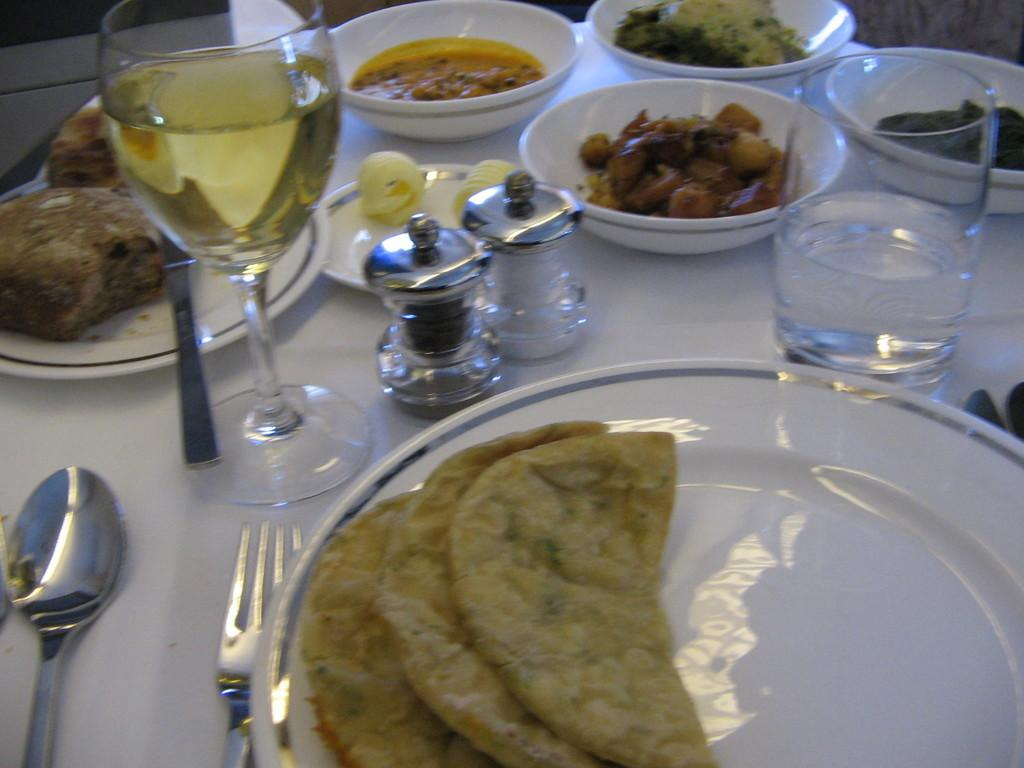What types of tableware are visible in the image? There are plates, bowls, glasses, and spoons in the image. Is there any cutlery present in the image? Yes, there is a fork in the image. What else can be seen in the image besides tableware? Food is present in the image. What type of chalk is being used to draw on the plates in the image? There is no chalk present in the image, and the plates are not being used for drawing. 